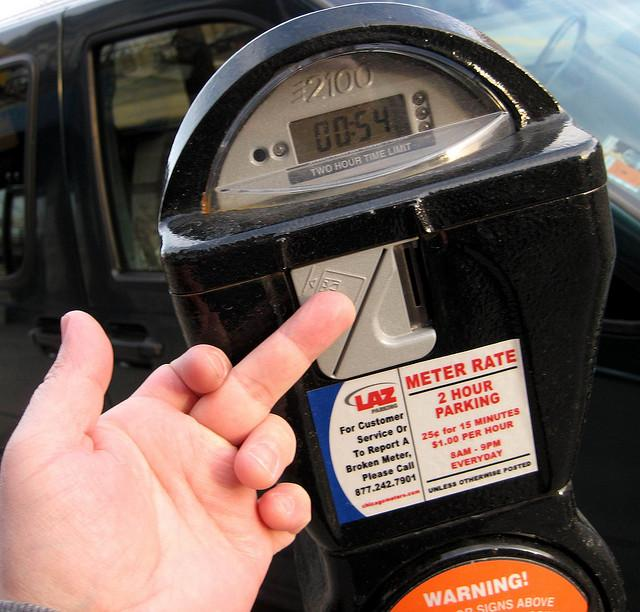What are they doing? parking 